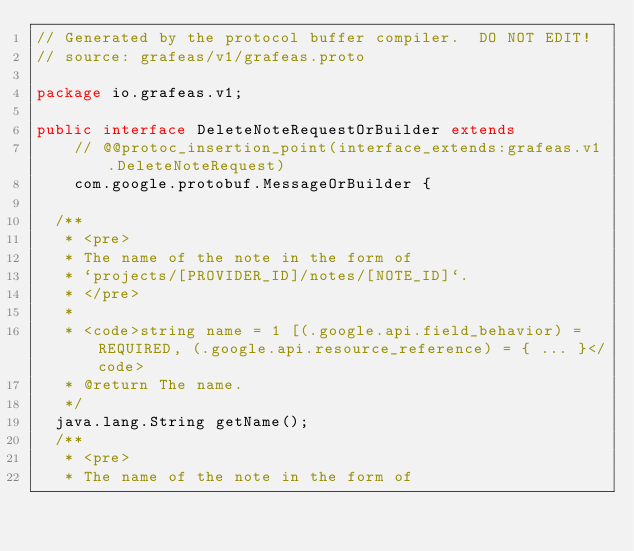Convert code to text. <code><loc_0><loc_0><loc_500><loc_500><_Java_>// Generated by the protocol buffer compiler.  DO NOT EDIT!
// source: grafeas/v1/grafeas.proto

package io.grafeas.v1;

public interface DeleteNoteRequestOrBuilder extends
    // @@protoc_insertion_point(interface_extends:grafeas.v1.DeleteNoteRequest)
    com.google.protobuf.MessageOrBuilder {

  /**
   * <pre>
   * The name of the note in the form of
   * `projects/[PROVIDER_ID]/notes/[NOTE_ID]`.
   * </pre>
   *
   * <code>string name = 1 [(.google.api.field_behavior) = REQUIRED, (.google.api.resource_reference) = { ... }</code>
   * @return The name.
   */
  java.lang.String getName();
  /**
   * <pre>
   * The name of the note in the form of</code> 